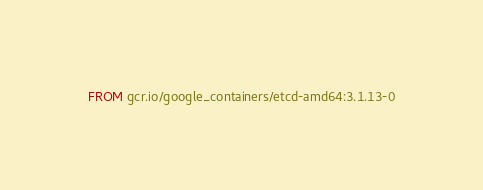<code> <loc_0><loc_0><loc_500><loc_500><_Dockerfile_>FROM gcr.io/google_containers/etcd-amd64:3.1.13-0
</code> 